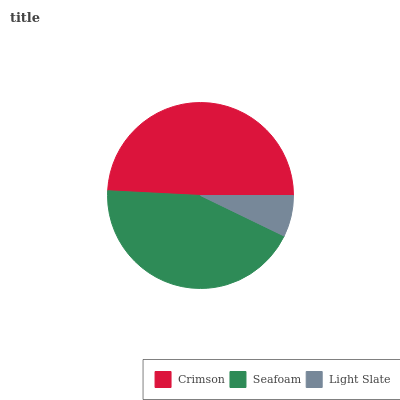Is Light Slate the minimum?
Answer yes or no. Yes. Is Crimson the maximum?
Answer yes or no. Yes. Is Seafoam the minimum?
Answer yes or no. No. Is Seafoam the maximum?
Answer yes or no. No. Is Crimson greater than Seafoam?
Answer yes or no. Yes. Is Seafoam less than Crimson?
Answer yes or no. Yes. Is Seafoam greater than Crimson?
Answer yes or no. No. Is Crimson less than Seafoam?
Answer yes or no. No. Is Seafoam the high median?
Answer yes or no. Yes. Is Seafoam the low median?
Answer yes or no. Yes. Is Crimson the high median?
Answer yes or no. No. Is Crimson the low median?
Answer yes or no. No. 